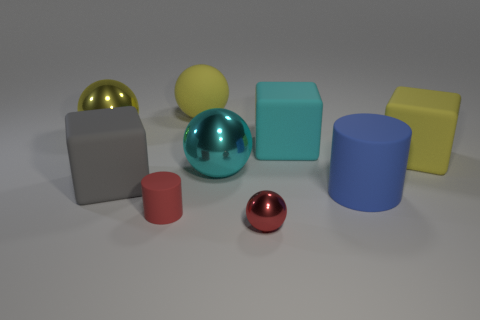Can you tell me what the colors of the spherical objects are? The spherical objects feature various colors: one is golden, another is cyan, and the third is red. 